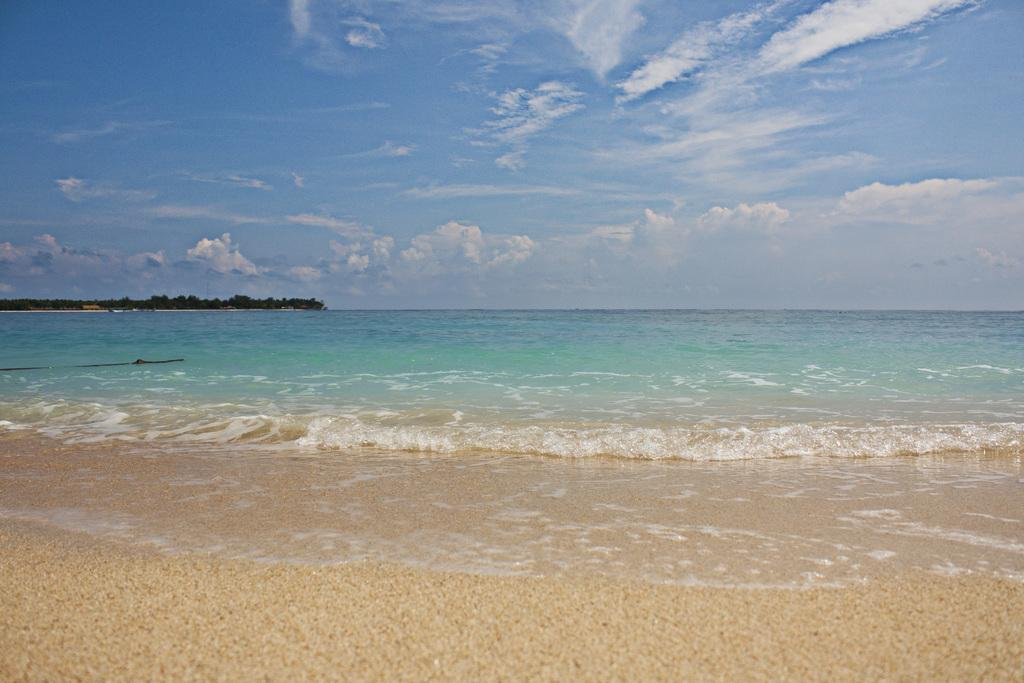What type of natural environment is depicted in the image? The image shows an ocean. What two elements are present in the image that are commonly found near the ocean? There is water and sand in the image. What can be seen in the background of the image? There are trees in the background of the image. What is visible in the sky in the image? The sky is visible in the image, and clouds are present. Can you see your friend playing with a quince in the image? There is no friend or quince present in the image; it depicts an ocean scene with water, sand, trees, and a cloudy sky. 